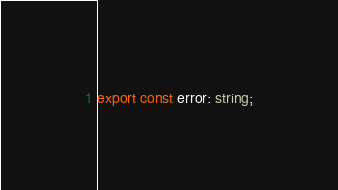Convert code to text. <code><loc_0><loc_0><loc_500><loc_500><_TypeScript_>export const error: string;</code> 